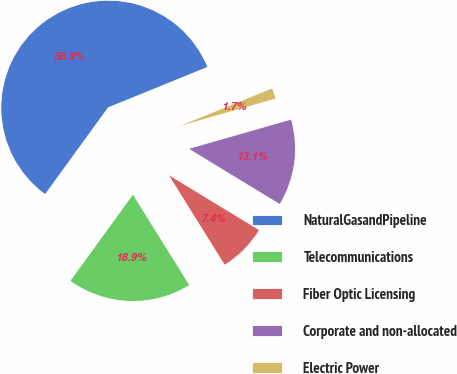<chart> <loc_0><loc_0><loc_500><loc_500><pie_chart><fcel>NaturalGasandPipeline<fcel>Telecommunications<fcel>Fiber Optic Licensing<fcel>Corporate and non-allocated<fcel>Electric Power<nl><fcel>58.86%<fcel>18.86%<fcel>7.43%<fcel>13.14%<fcel>1.71%<nl></chart> 